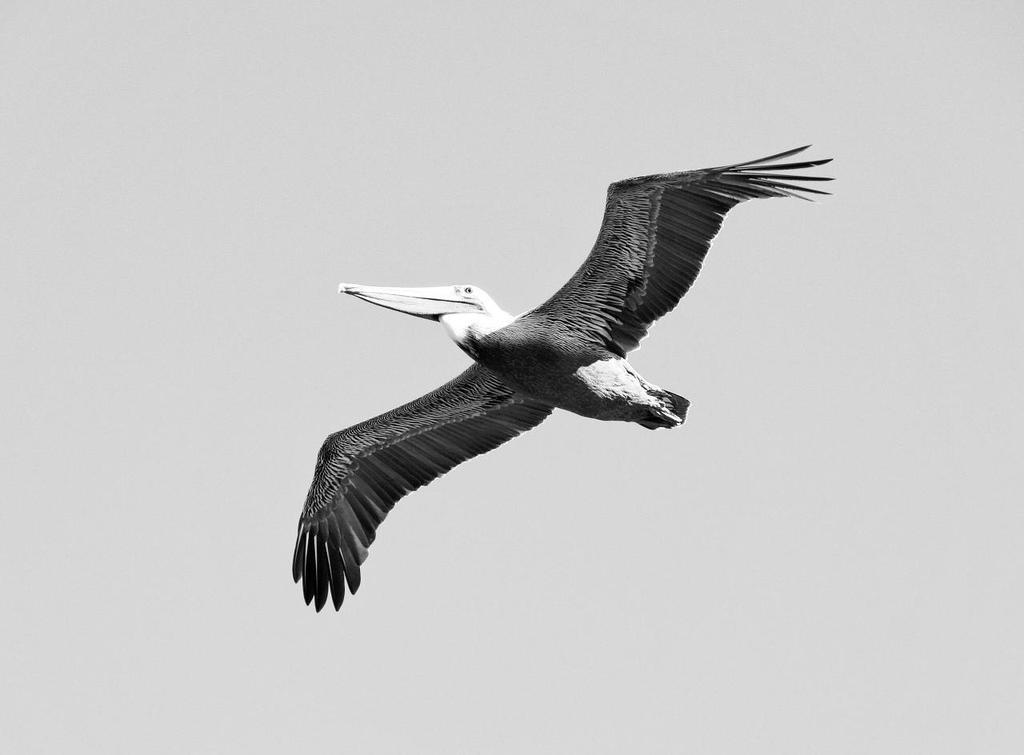What type of animal is in the image? There is a bird in the image. What is the bird doing in the image? The bird is flying in the air. Can you describe any specific features of the bird? The bird has a long beak. What type of law does the bird practice in the image? There is no indication in the image that the bird is a lawyer or practices law. 